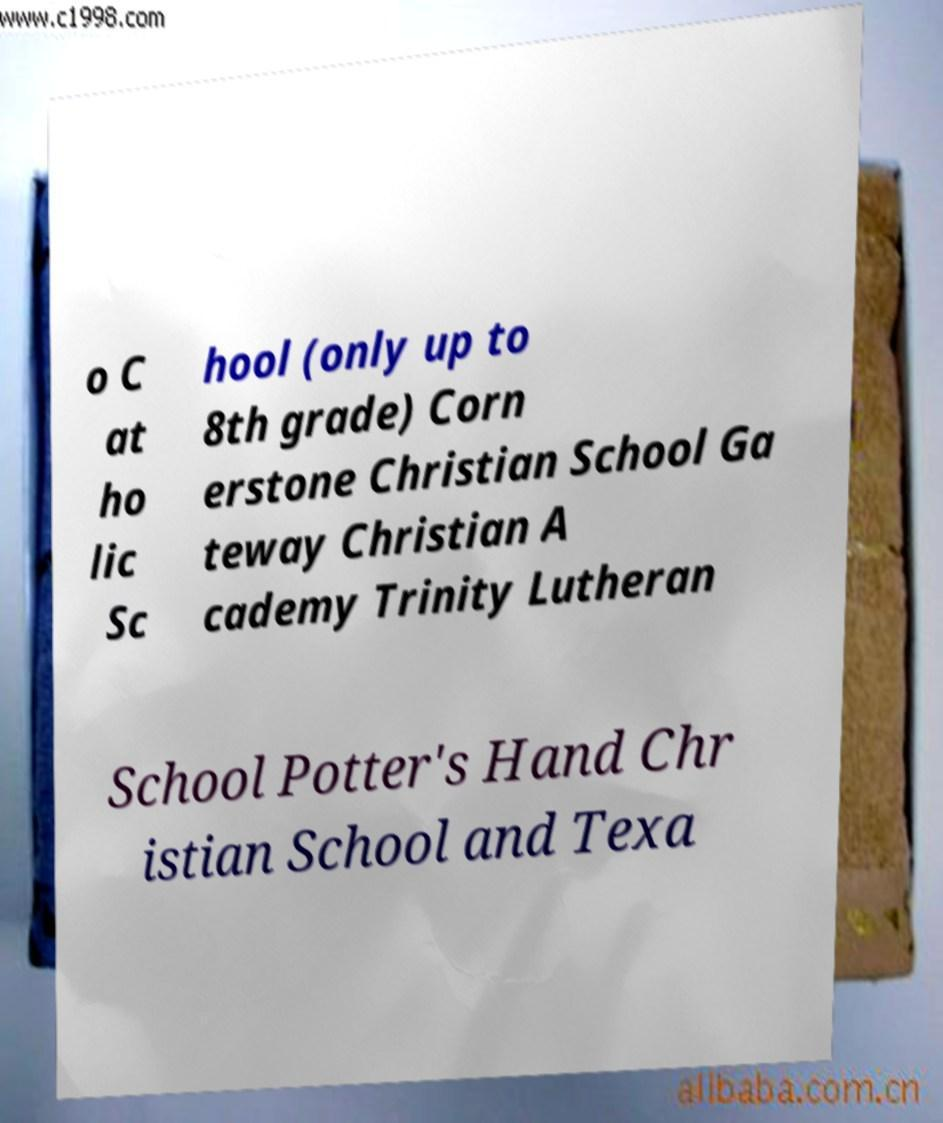Please read and relay the text visible in this image. What does it say? o C at ho lic Sc hool (only up to 8th grade) Corn erstone Christian School Ga teway Christian A cademy Trinity Lutheran School Potter's Hand Chr istian School and Texa 